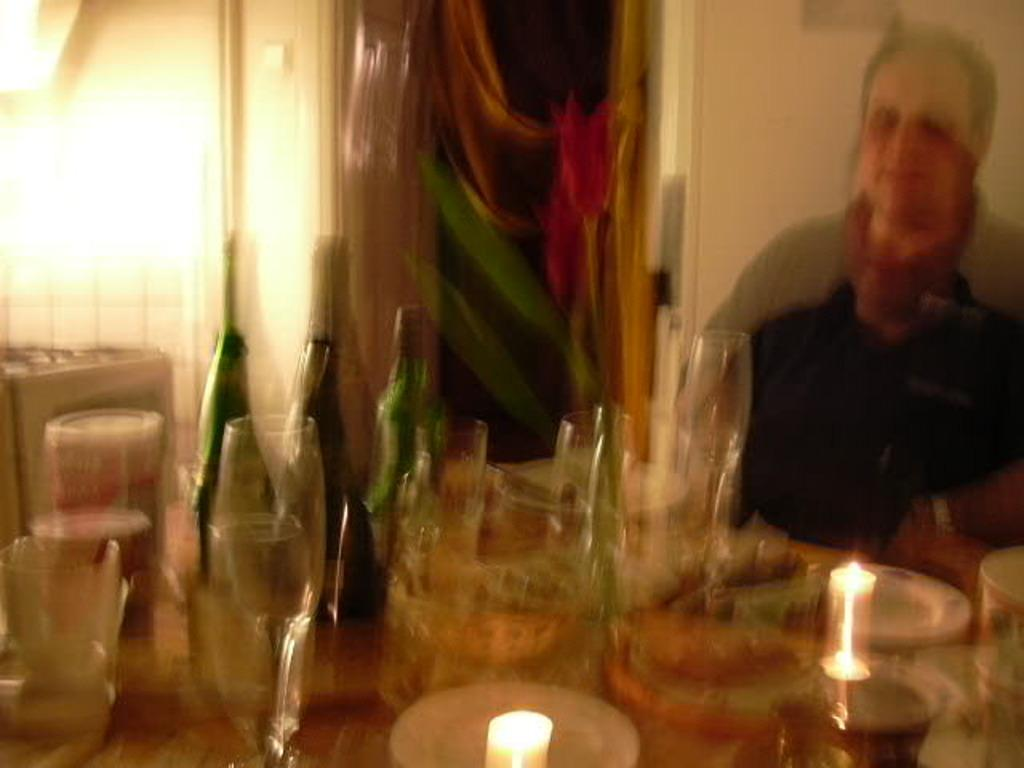What type of furniture is in the image? There is a dining table in the image. What items can be seen on the table? Wine glasses, bottles, bowls, and candles are on the table. Who is present at the table? There is a man sitting on the right side of the table. What is visible in the background of the image? There is a wall in the background of the image. How many dolls are sitting on the table in the image? There are no dolls present in the image. What type of bear can be seen interacting with the candles on the table? There is no bear present in the image; only the man, wine glasses, bottles, bowls, and candles are visible. 